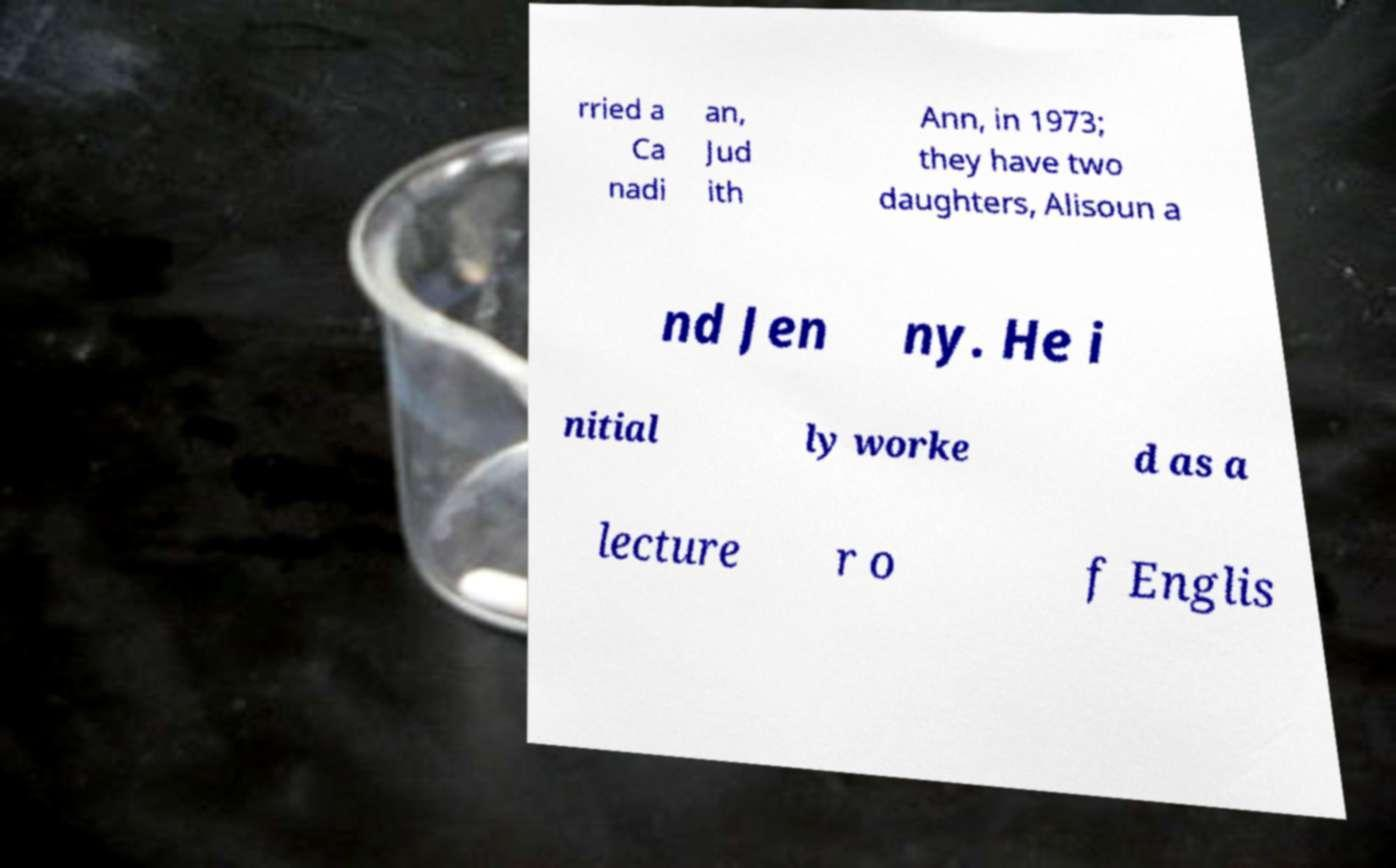Could you assist in decoding the text presented in this image and type it out clearly? rried a Ca nadi an, Jud ith Ann, in 1973; they have two daughters, Alisoun a nd Jen ny. He i nitial ly worke d as a lecture r o f Englis 